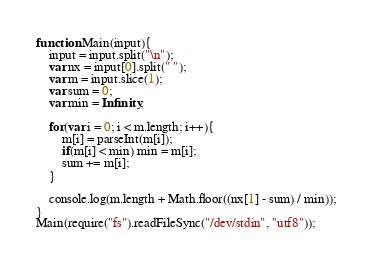<code> <loc_0><loc_0><loc_500><loc_500><_JavaScript_>function Main(input){
    input = input.split("\n");
    var nx = input[0].split(" ");
    var m = input.slice(1);
    var sum = 0;
    var min = Infinity;
    
    for(var i = 0; i < m.length; i++){
		m[i] = parseInt(m[i]);
        if(m[i] < min) min = m[i];
        sum += m[i];
    }
    
    console.log(m.length + Math.floor((nx[1] - sum) / min));
}
Main(require("fs").readFileSync("/dev/stdin", "utf8"));</code> 